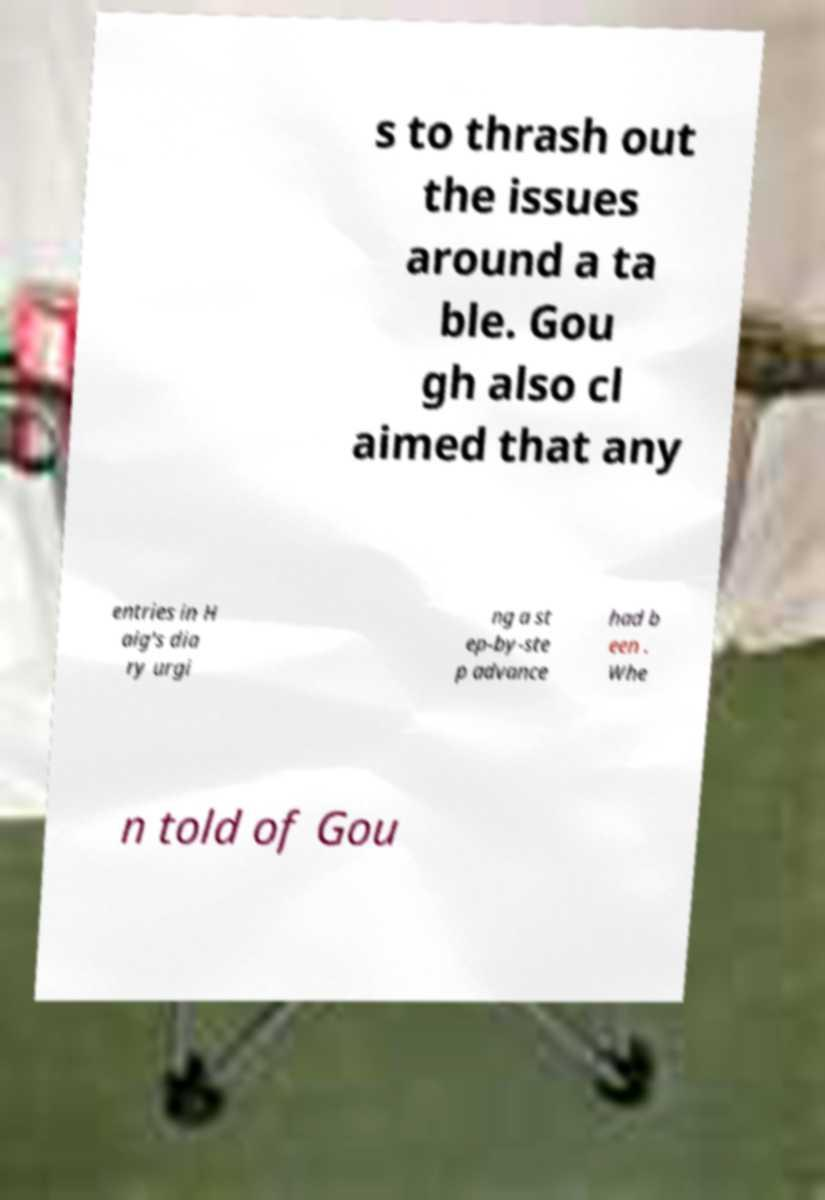Could you extract and type out the text from this image? s to thrash out the issues around a ta ble. Gou gh also cl aimed that any entries in H aig's dia ry urgi ng a st ep-by-ste p advance had b een . Whe n told of Gou 